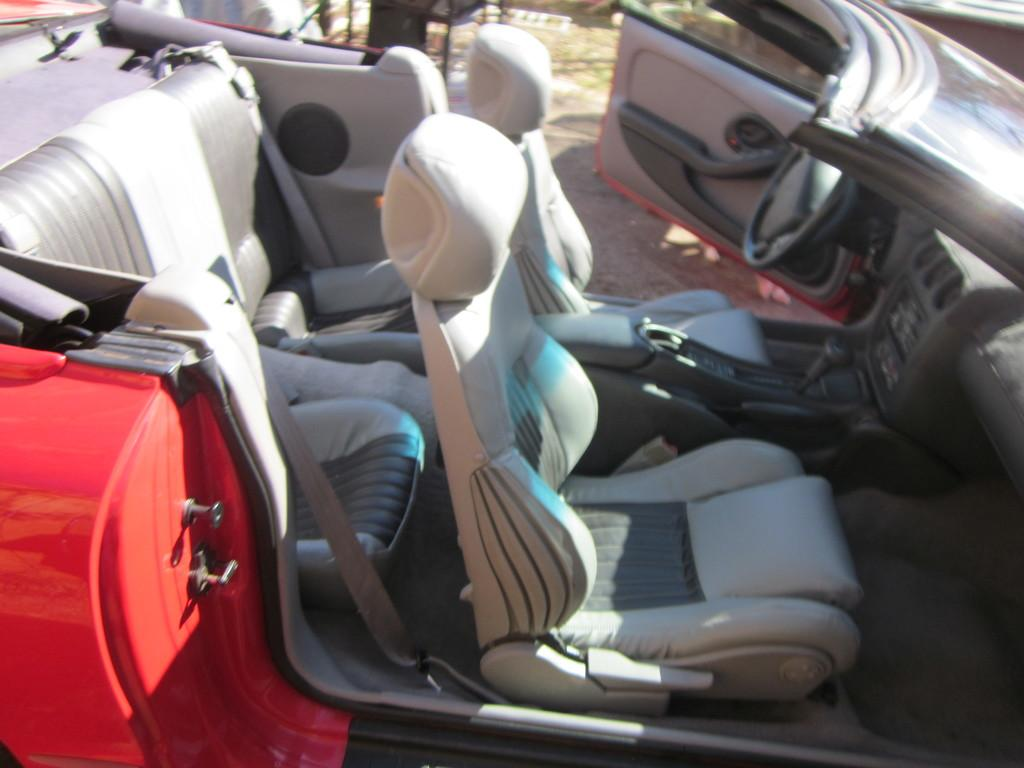What is the main subject of the picture? The main subject of the picture is a car. What features can be seen inside the car? The car has seats and a steering wheel. What type of school can be seen in the background of the image? There is no school present in the image; it features a car with seats and a steering wheel. What kind of arch is visible above the car in the image? There is no arch present in the image; it features a car with seats and a steering wheel. 